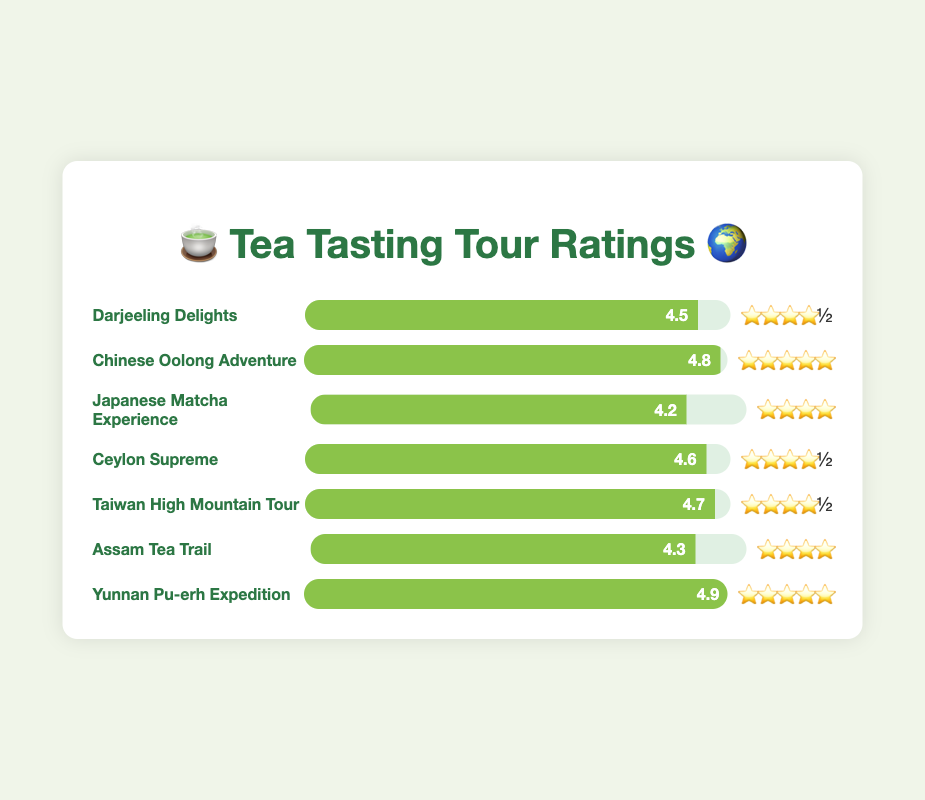What is the rating for the "Darjeeling Delights" tour? The rating for "Darjeeling Delights" is given in the figure as 4.5, which is displayed directly to the right of the tour name.
Answer: 4.5 Which tour has the highest customer satisfaction rating? "Yunnan Pu-erh Expedition" has a rating of 4.9, which is the highest among all listed tours. This can be identified by checking the ratings of all tours listed.
Answer: Yunnan Pu-erh Expedition How many tours have a rating of at least 4.5 stars? By looking at the ratings, "Darjeeling Delights (4.5)", "Chinese Oolong Adventure (4.8)", "Ceylon Supreme (4.6)", "Taiwan High Mountain Tour (4.7)", and "Yunnan Pu-erh Expedition (4.9)" all have ratings of 4.5 or higher. That gives us 5 tours.
Answer: 5 What is the average rating of all the tours shown? Add all the ratings together: 4.5 + 4.8 + 4.2 + 4.6 + 4.7 + 4.3 + 4.9 = 32. Then, divide by the number of tours, which is 7: 32/7 ≈ 4.57.
Answer: 4.57 Which tour has a higher rating: "Assam Tea Trail" or "Japanese Matcha Experience"? Compare the ratings directly. "Assam Tea Trail" has a rating of 4.3, while "Japanese Matcha Experience" has a rating of 4.2.
Answer: Assam Tea Trail How much higher is the rating of "Chinese Oolong Adventure" compared to "Japanese Matcha Experience"? Subtract the rating of "Japanese Matcha Experience" from the rating of "Chinese Oolong Adventure": 4.8 - 4.2 = 0.6. This shows that "Chinese Oolong Adventure" has a rating 0.6 points higher.
Answer: 0.6 Which tour has the second highest rating? "Yunnan Pu-erh Expedition" has the highest rating with 4.9. The second highest rating is "Chinese Oolong Adventure" with 4.8.
Answer: Chinese Oolong Adventure Do more tours have ratings above 4.5 or below 4.5? Count the tours with ratings above 4.5 ("Chinese Oolong Adventure", "Ceylon Supreme", "Taiwan High Mountain Tour", "Yunnan Pu-erh Expedition") and those below 4.5 ("Japanese Matcha Experience", "Assam Tea Trail"). 4 tours have ratings above 4.5, and 2 have ratings below.
Answer: Above 4.5 Which tour has the fewest stars in its rating? The tour with the fewest stars is "Japanese Matcha Experience" with a rating of 4.2 stars.
Answer: Japanese Matcha Experience What's the total of all customer satisfaction ratings? Add all the ratings together: 4.5 (Darjeeling Delights) + 4.8 (Chinese Oolong Adventure) + 4.2 (Japanese Matcha Experience) + 4.6 (Ceylon Supreme) + 4.7 (Taiwan High Mountain Tour) + 4.3 (Assam Tea Trail) + 4.9 (Yunnan Pu-erh Expedition) = 32.0.
Answer: 32.0 